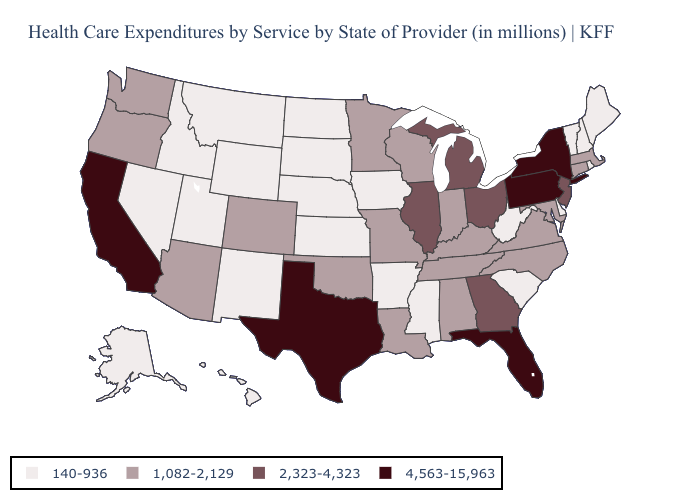What is the value of Michigan?
Be succinct. 2,323-4,323. Name the states that have a value in the range 2,323-4,323?
Be succinct. Georgia, Illinois, Michigan, New Jersey, Ohio. Name the states that have a value in the range 140-936?
Concise answer only. Alaska, Arkansas, Delaware, Hawaii, Idaho, Iowa, Kansas, Maine, Mississippi, Montana, Nebraska, Nevada, New Hampshire, New Mexico, North Dakota, Rhode Island, South Carolina, South Dakota, Utah, Vermont, West Virginia, Wyoming. Name the states that have a value in the range 2,323-4,323?
Concise answer only. Georgia, Illinois, Michigan, New Jersey, Ohio. Does Florida have the highest value in the South?
Keep it brief. Yes. What is the highest value in the West ?
Be succinct. 4,563-15,963. Which states have the lowest value in the MidWest?
Short answer required. Iowa, Kansas, Nebraska, North Dakota, South Dakota. What is the value of South Carolina?
Give a very brief answer. 140-936. Does the first symbol in the legend represent the smallest category?
Write a very short answer. Yes. Which states have the lowest value in the Northeast?
Keep it brief. Maine, New Hampshire, Rhode Island, Vermont. What is the lowest value in states that border Arizona?
Give a very brief answer. 140-936. Does Hawaii have the lowest value in the USA?
Short answer required. Yes. Name the states that have a value in the range 1,082-2,129?
Short answer required. Alabama, Arizona, Colorado, Connecticut, Indiana, Kentucky, Louisiana, Maryland, Massachusetts, Minnesota, Missouri, North Carolina, Oklahoma, Oregon, Tennessee, Virginia, Washington, Wisconsin. How many symbols are there in the legend?
Keep it brief. 4. What is the highest value in the USA?
Quick response, please. 4,563-15,963. 